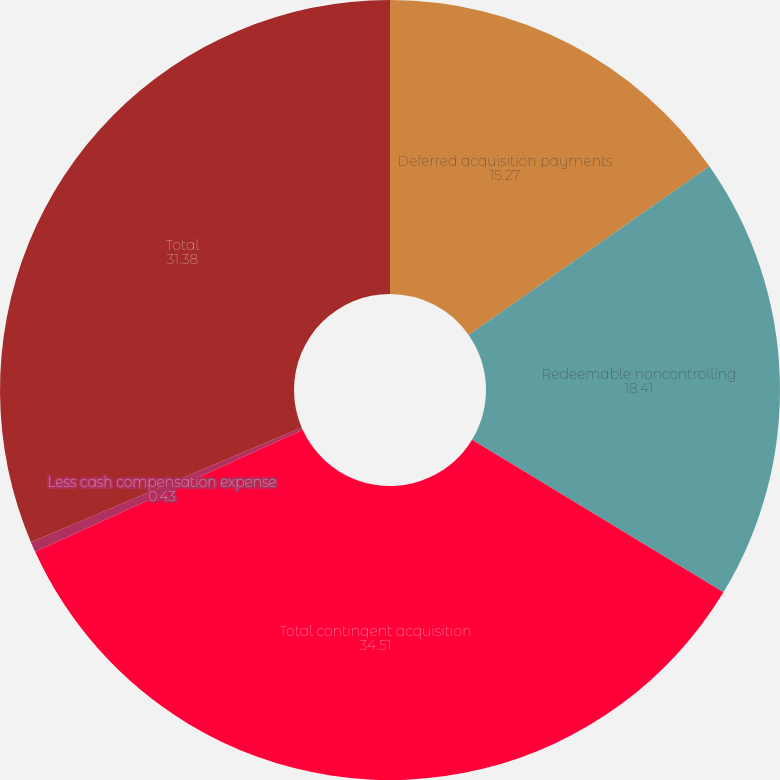Convert chart to OTSL. <chart><loc_0><loc_0><loc_500><loc_500><pie_chart><fcel>Deferred acquisition payments<fcel>Redeemable noncontrolling<fcel>Total contingent acquisition<fcel>Less cash compensation expense<fcel>Total<nl><fcel>15.27%<fcel>18.41%<fcel>34.51%<fcel>0.43%<fcel>31.38%<nl></chart> 